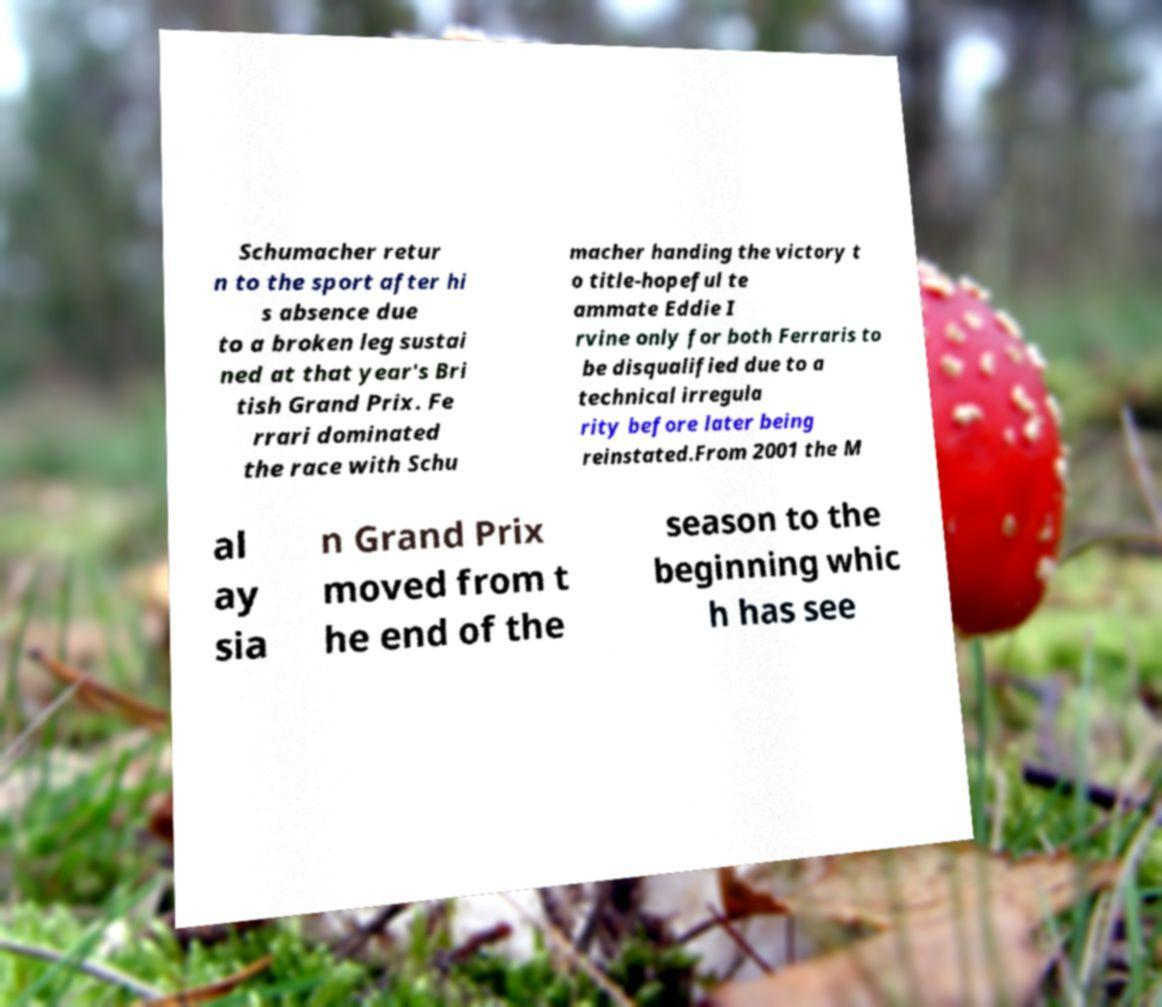Could you assist in decoding the text presented in this image and type it out clearly? Schumacher retur n to the sport after hi s absence due to a broken leg sustai ned at that year's Bri tish Grand Prix. Fe rrari dominated the race with Schu macher handing the victory t o title-hopeful te ammate Eddie I rvine only for both Ferraris to be disqualified due to a technical irregula rity before later being reinstated.From 2001 the M al ay sia n Grand Prix moved from t he end of the season to the beginning whic h has see 